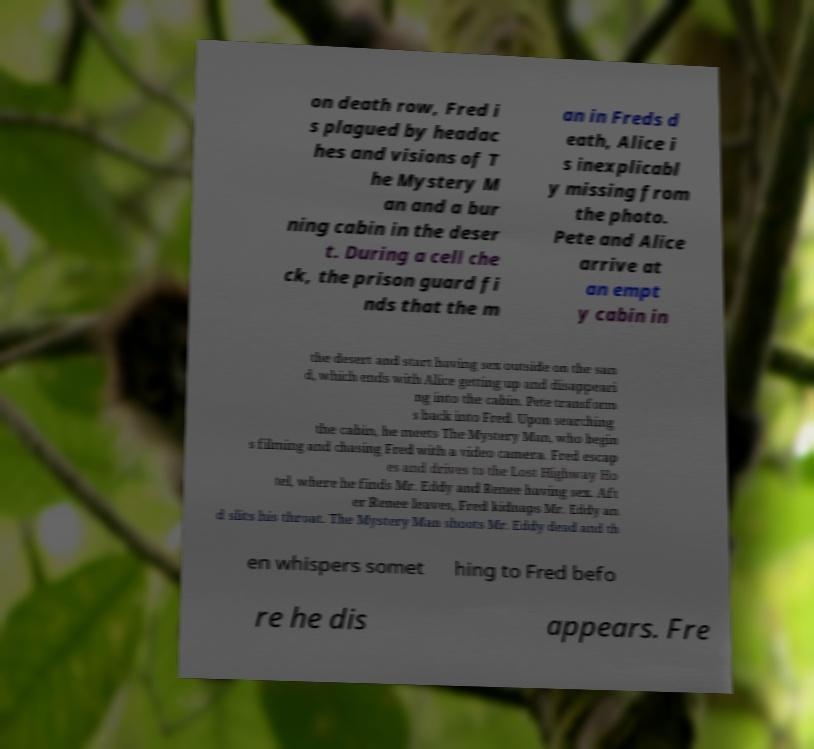Can you accurately transcribe the text from the provided image for me? on death row, Fred i s plagued by headac hes and visions of T he Mystery M an and a bur ning cabin in the deser t. During a cell che ck, the prison guard fi nds that the m an in Freds d eath, Alice i s inexplicabl y missing from the photo. Pete and Alice arrive at an empt y cabin in the desert and start having sex outside on the san d, which ends with Alice getting up and disappeari ng into the cabin. Pete transform s back into Fred. Upon searching the cabin, he meets The Mystery Man, who begin s filming and chasing Fred with a video camera. Fred escap es and drives to the Lost Highway Ho tel, where he finds Mr. Eddy and Renee having sex. Aft er Renee leaves, Fred kidnaps Mr. Eddy an d slits his throat. The Mystery Man shoots Mr. Eddy dead and th en whispers somet hing to Fred befo re he dis appears. Fre 